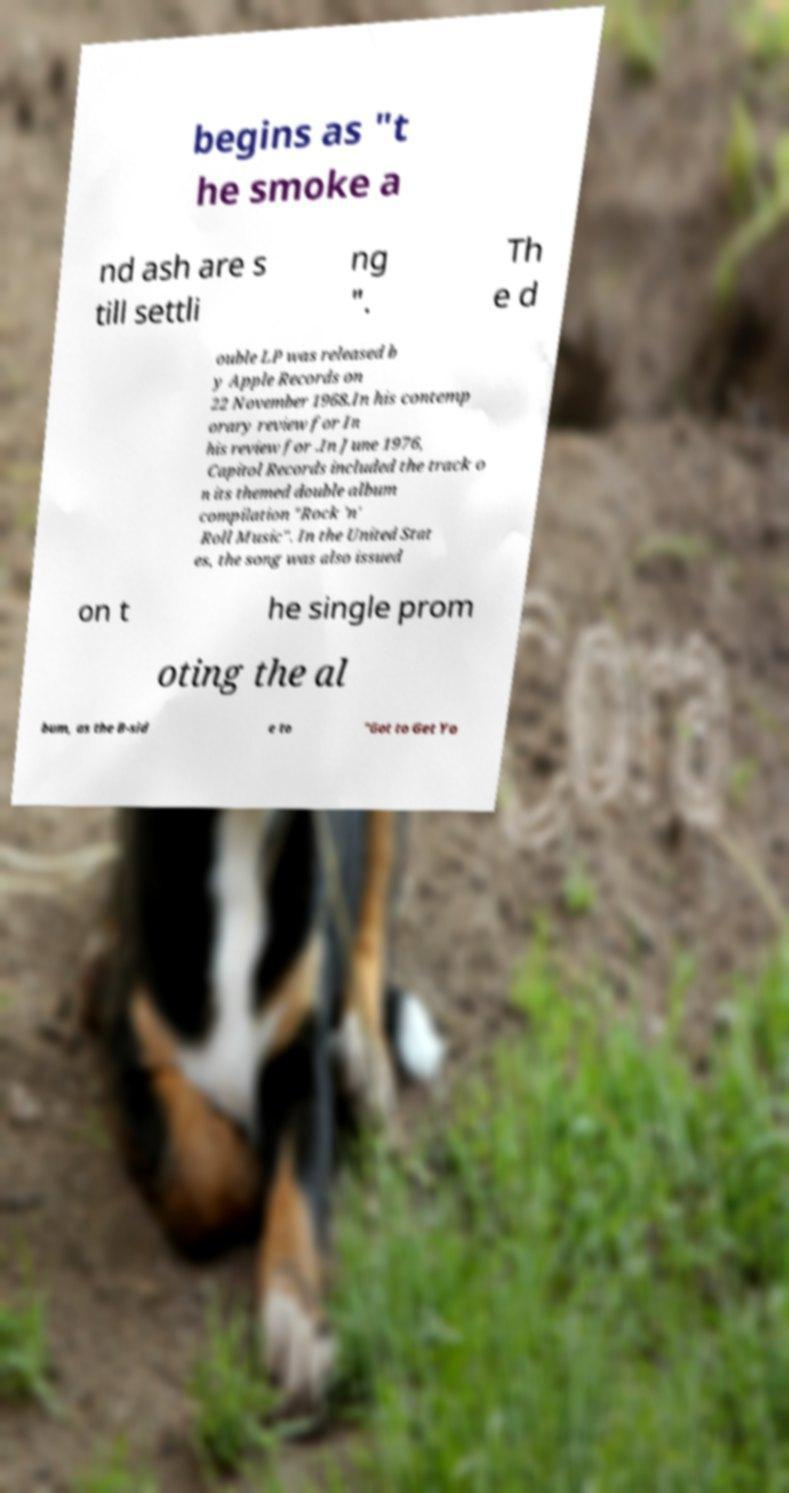Could you assist in decoding the text presented in this image and type it out clearly? begins as "t he smoke a nd ash are s till settli ng ". Th e d ouble LP was released b y Apple Records on 22 November 1968.In his contemp orary review for In his review for .In June 1976, Capitol Records included the track o n its themed double album compilation "Rock 'n' Roll Music". In the United Stat es, the song was also issued on t he single prom oting the al bum, as the B-sid e to "Got to Get Yo 